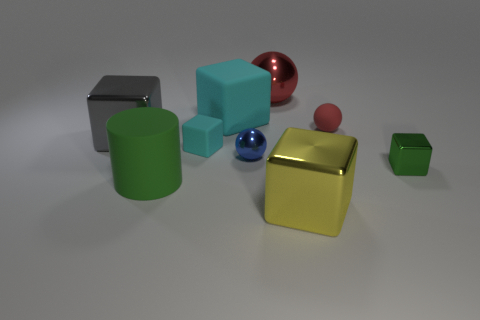Are there fewer green things than tiny purple metallic cylinders?
Make the answer very short. No. There is a gray metal block; does it have the same size as the green object on the left side of the small green cube?
Your answer should be very brief. Yes. Is there anything else that is the same shape as the red metallic thing?
Provide a succinct answer. Yes. The yellow block is what size?
Give a very brief answer. Large. Are there fewer gray things in front of the tiny cyan object than large blue spheres?
Your answer should be compact. No. Do the gray thing and the green metallic block have the same size?
Offer a very short reply. No. Is there any other thing that is the same size as the gray thing?
Your response must be concise. Yes. What color is the big block that is the same material as the small red sphere?
Ensure brevity in your answer.  Cyan. Are there fewer blocks in front of the tiny rubber block than small cubes in front of the big yellow shiny cube?
Your answer should be compact. No. How many small matte things have the same color as the large cylinder?
Offer a terse response. 0. 